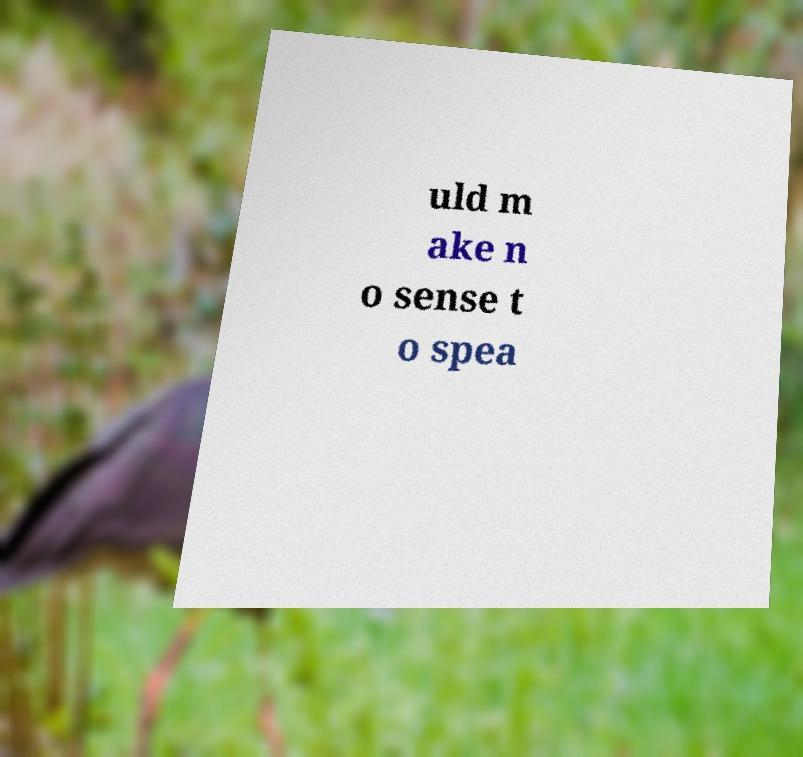For documentation purposes, I need the text within this image transcribed. Could you provide that? uld m ake n o sense t o spea 